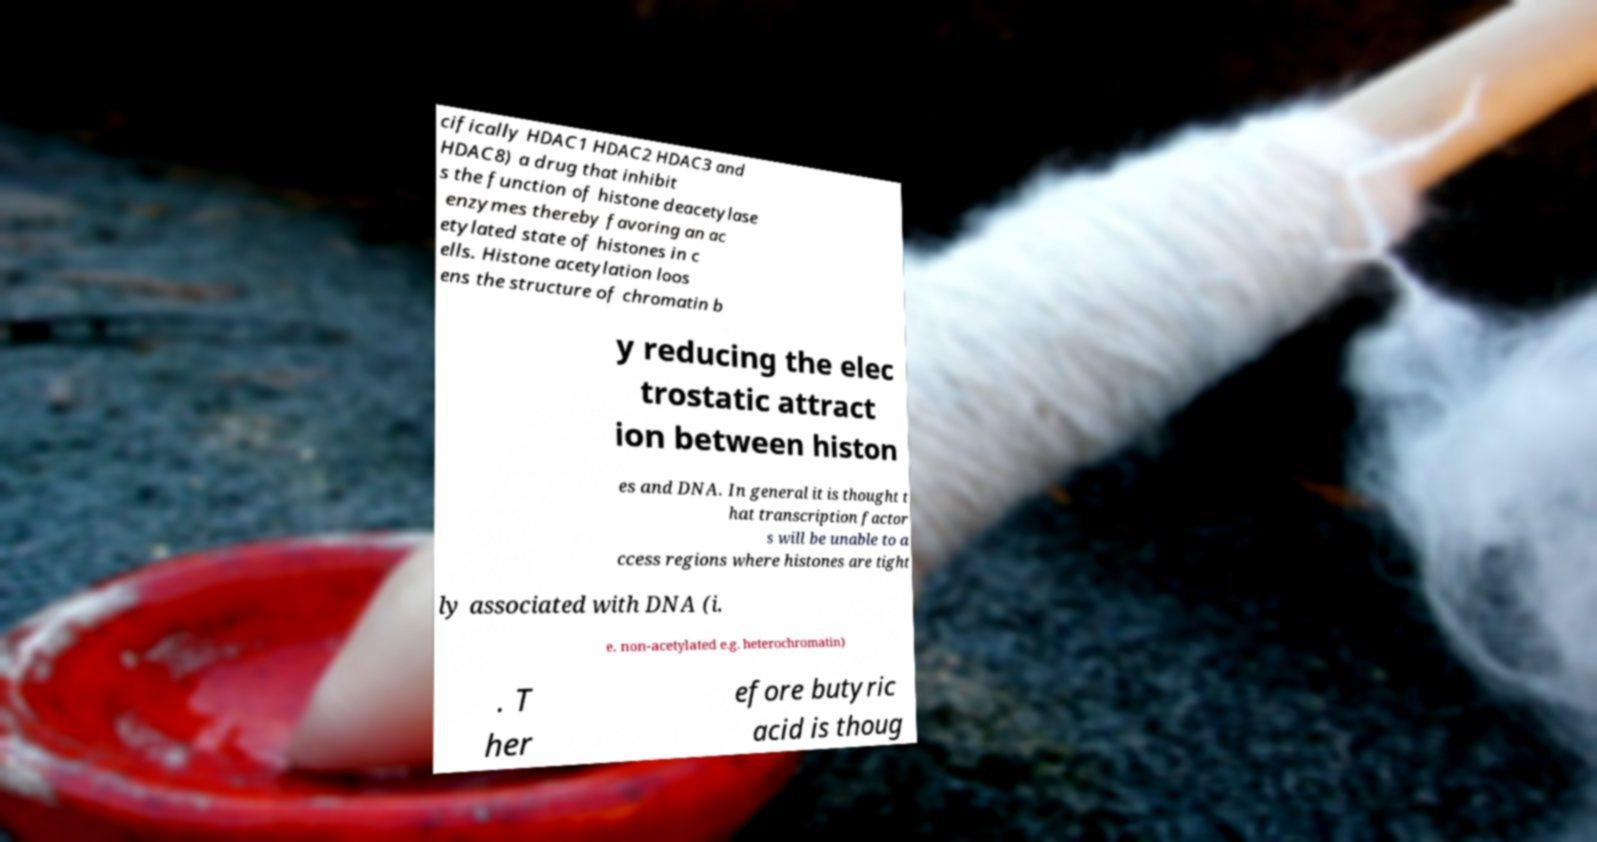For documentation purposes, I need the text within this image transcribed. Could you provide that? cifically HDAC1 HDAC2 HDAC3 and HDAC8) a drug that inhibit s the function of histone deacetylase enzymes thereby favoring an ac etylated state of histones in c ells. Histone acetylation loos ens the structure of chromatin b y reducing the elec trostatic attract ion between histon es and DNA. In general it is thought t hat transcription factor s will be unable to a ccess regions where histones are tight ly associated with DNA (i. e. non-acetylated e.g. heterochromatin) . T her efore butyric acid is thoug 